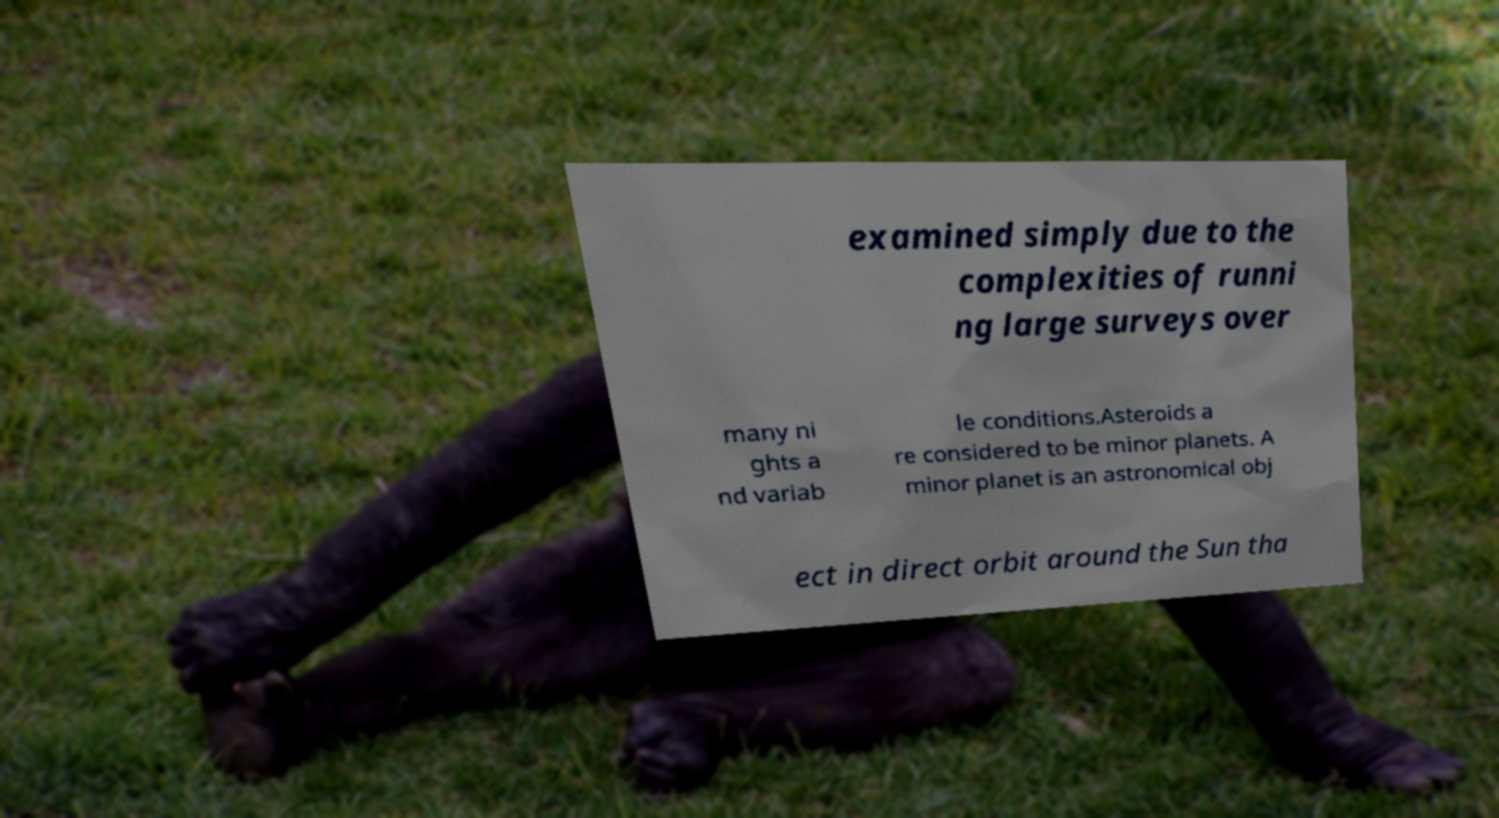Could you extract and type out the text from this image? examined simply due to the complexities of runni ng large surveys over many ni ghts a nd variab le conditions.Asteroids a re considered to be minor planets. A minor planet is an astronomical obj ect in direct orbit around the Sun tha 